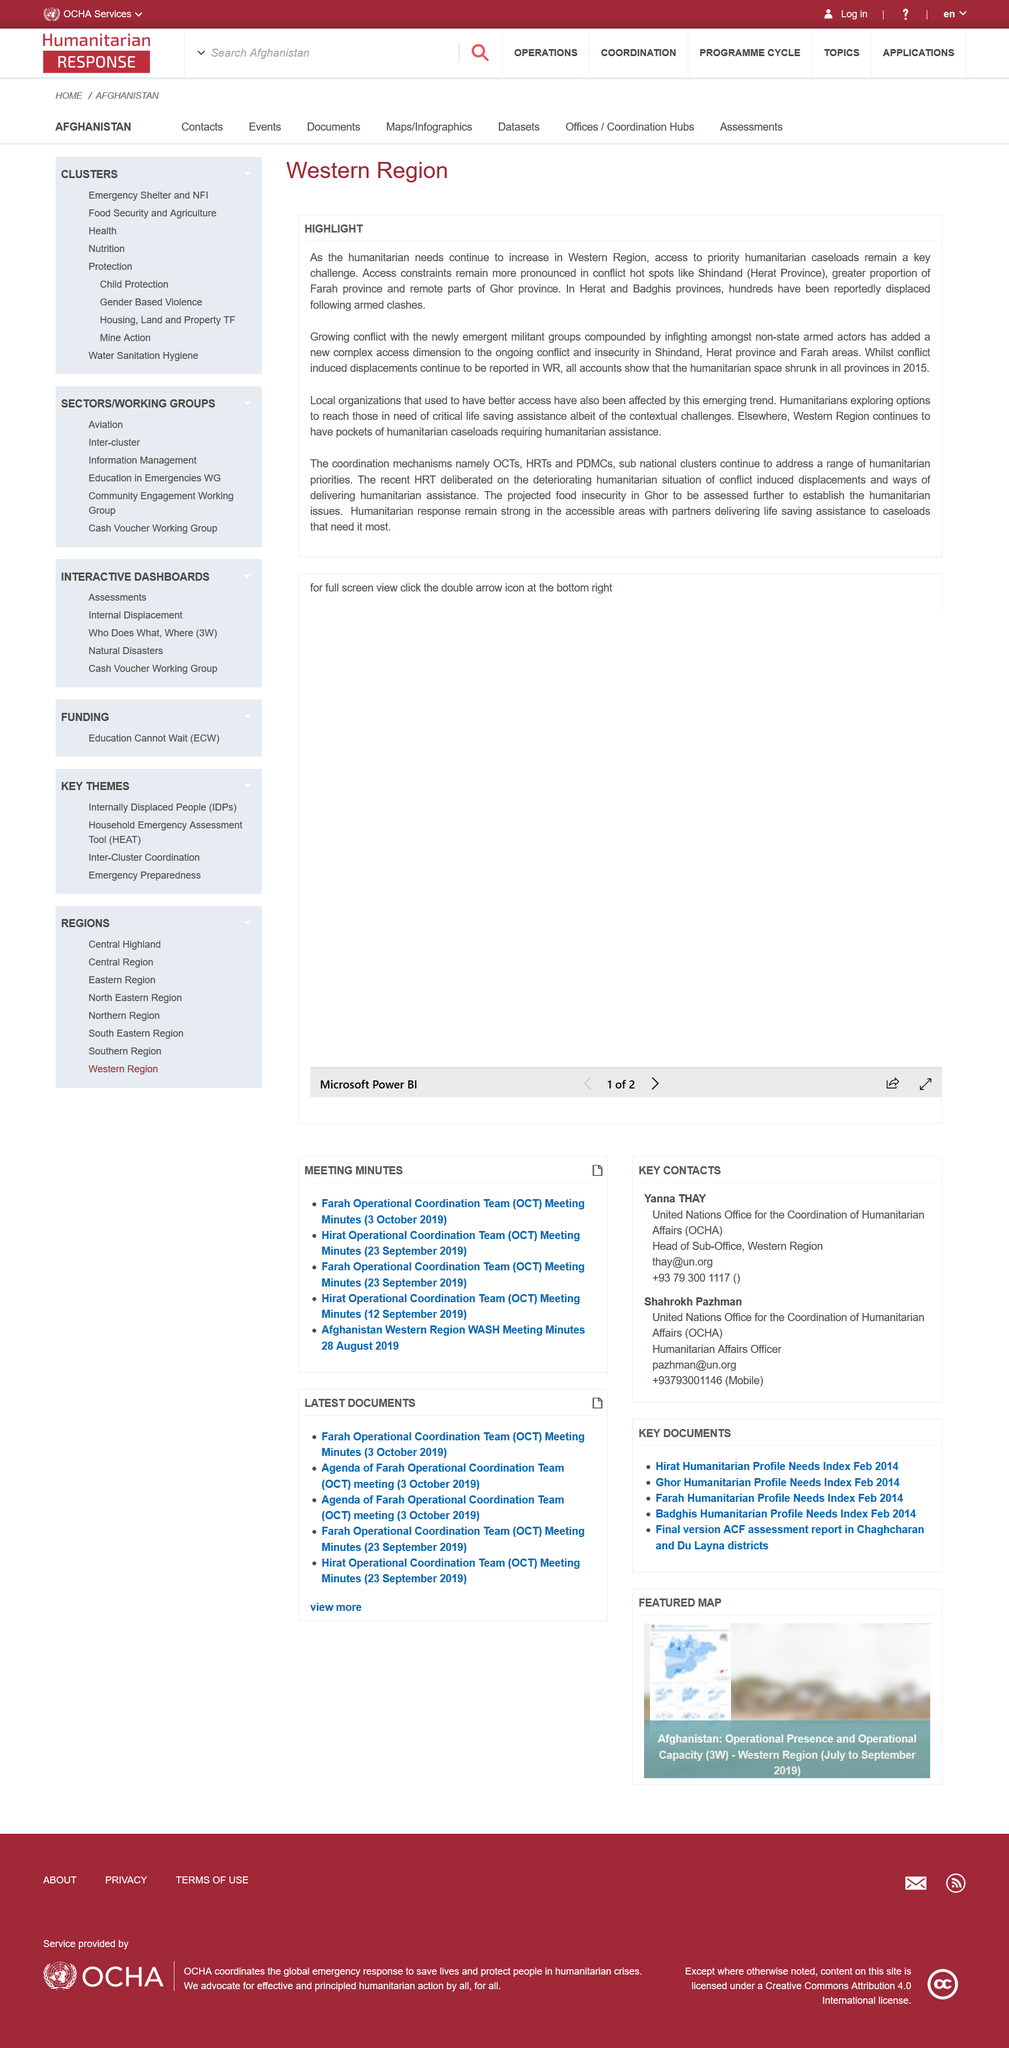Highlight a few significant elements in this photo. In 2015, humanitarian spaces decreased in all provinces, leading to a decline in access to essential services and support for vulnerable communities. In Herat and Badghis provinces, it has been reported that hundreds of people have been displaced. The mentioned Western Region conflict hot spot is Shindand (Herat Province). 